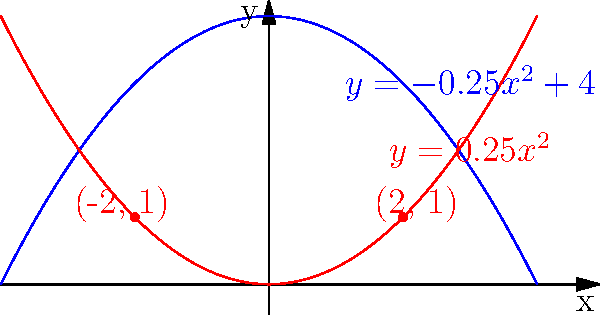In the design of a cathedral, two parabolic arches are represented by the equations $y = -0.25x^2 + 4$ and $y = 0.25x^2$. These arches intersect at two points, creating a sacred space between them. What is the area enclosed between these two parabolas? To find the area between the two parabolas, we need to follow these steps:

1) First, we need to find the points of intersection. We can do this by setting the equations equal to each other:

   $-0.25x^2 + 4 = 0.25x^2$
   $4 = 0.5x^2$
   $x^2 = 8$
   $x = \pm 2\sqrt{2} \approx \pm 2.83$

2) The points of intersection are $(-2\sqrt{2}, 2)$ and $(2\sqrt{2}, 2)$.

3) To find the area, we need to integrate the difference between the two functions from $-2\sqrt{2}$ to $2\sqrt{2}$:

   $\text{Area} = \int_{-2\sqrt{2}}^{2\sqrt{2}} [(-0.25x^2 + 4) - (0.25x^2)] dx$

4) Simplify the integrand:
   
   $\text{Area} = \int_{-2\sqrt{2}}^{2\sqrt{2}} [-0.5x^2 + 4] dx$

5) Integrate:

   $\text{Area} = [-\frac{1}{6}x^3 + 4x]_{-2\sqrt{2}}^{2\sqrt{2}}$

6) Evaluate the integral:

   $\text{Area} = [-\frac{1}{6}(2\sqrt{2})^3 + 4(2\sqrt{2})] - [-\frac{1}{6}(-2\sqrt{2})^3 + 4(-2\sqrt{2})]$
                $= [-\frac{4\sqrt{2}}{3} + 8\sqrt{2}] - [\frac{4\sqrt{2}}{3} - 8\sqrt{2}]$
                $= -\frac{4\sqrt{2}}{3} + 8\sqrt{2} - \frac{4\sqrt{2}}{3} + 8\sqrt{2}$
                $= 16\sqrt{2} - \frac{8\sqrt{2}}{3}$
                $= \frac{40\sqrt{2}}{3}$

7) Therefore, the area enclosed between the two parabolas is $\frac{40\sqrt{2}}{3}$ square units.
Answer: $\frac{40\sqrt{2}}{3}$ square units 